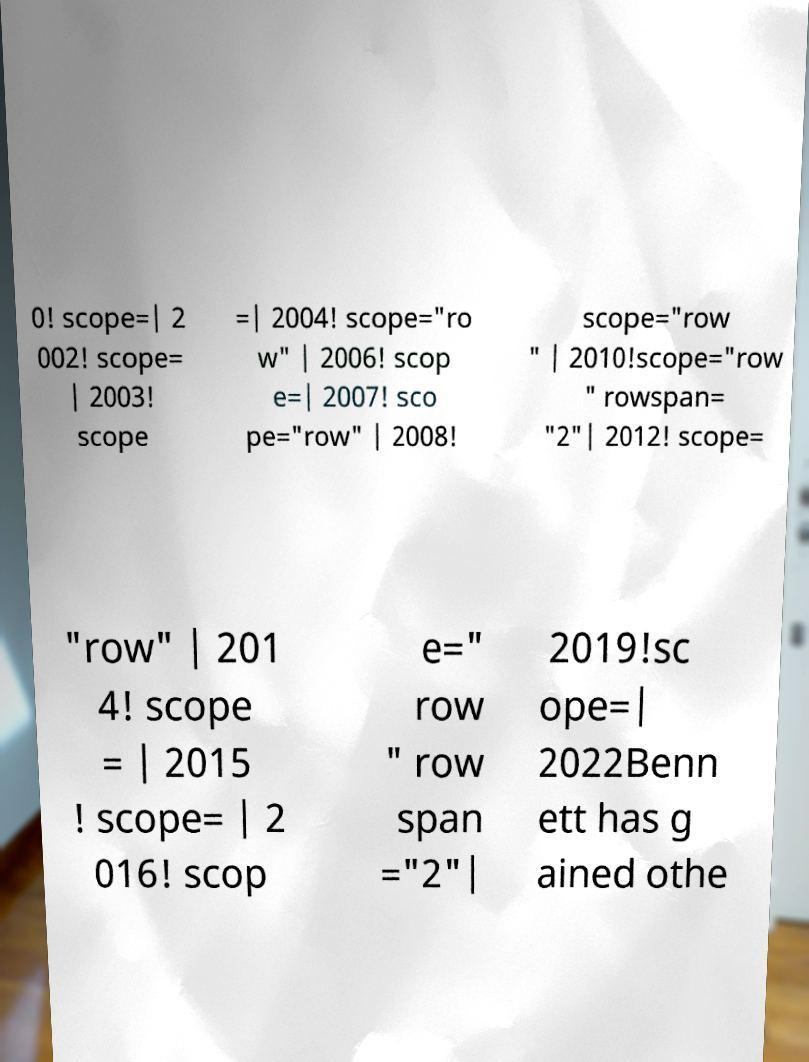For documentation purposes, I need the text within this image transcribed. Could you provide that? 0! scope=| 2 002! scope= | 2003! scope =| 2004! scope="ro w" | 2006! scop e=| 2007! sco pe="row" | 2008! scope="row " | 2010!scope="row " rowspan= "2"| 2012! scope= "row" | 201 4! scope = | 2015 ! scope= | 2 016! scop e=" row " row span ="2"| 2019!sc ope=| 2022Benn ett has g ained othe 